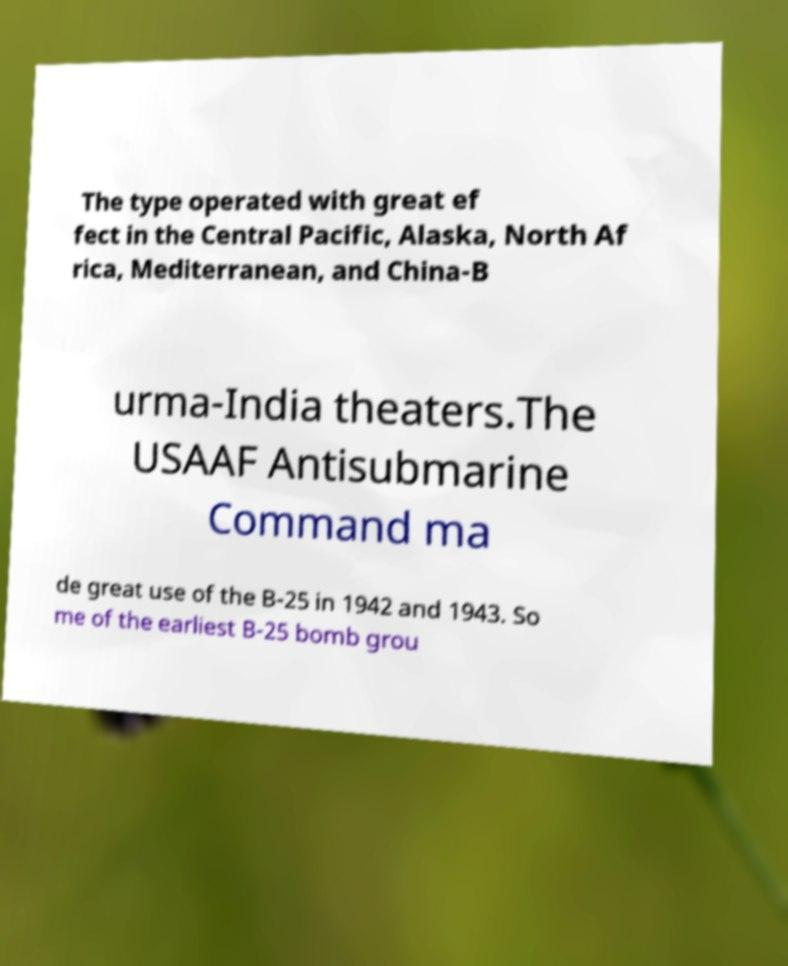What messages or text are displayed in this image? I need them in a readable, typed format. The type operated with great ef fect in the Central Pacific, Alaska, North Af rica, Mediterranean, and China-B urma-India theaters.The USAAF Antisubmarine Command ma de great use of the B-25 in 1942 and 1943. So me of the earliest B-25 bomb grou 